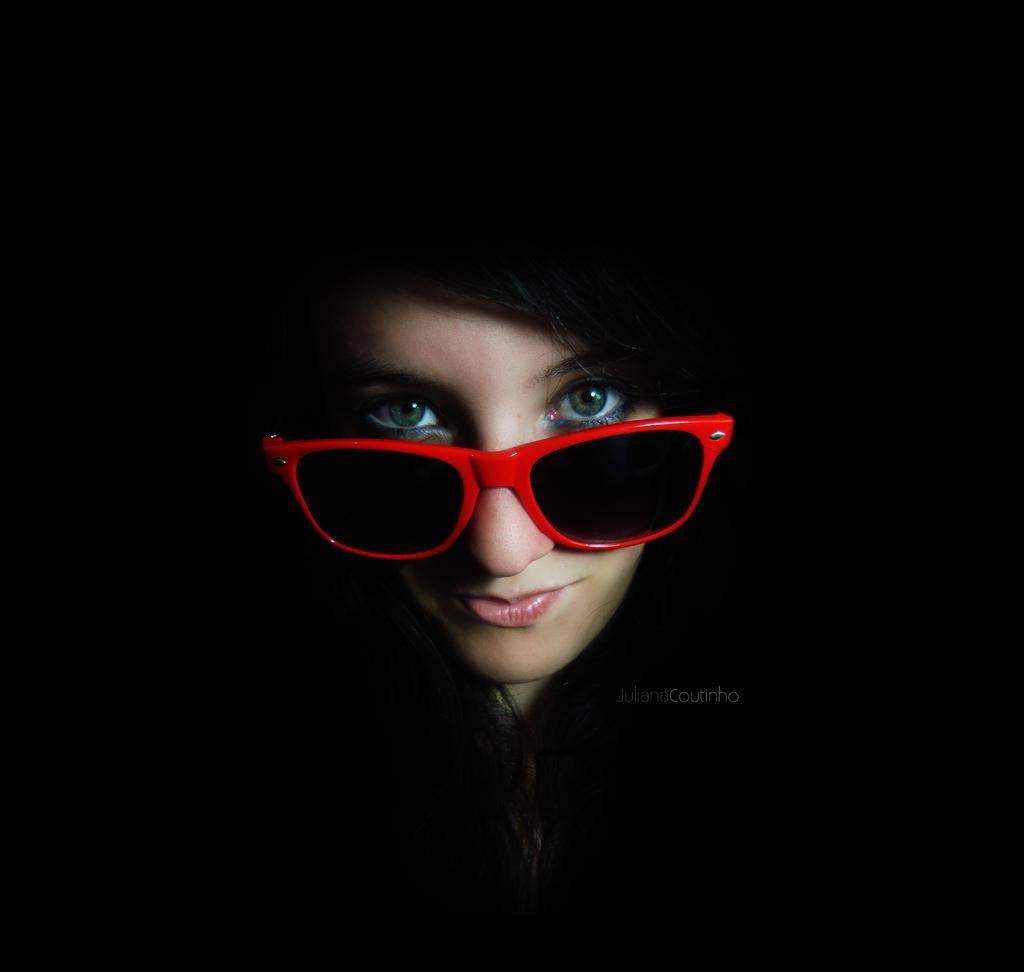Describe this image in one or two sentences. In the image we can see a woman, she wears glasses. 